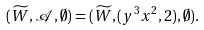Convert formula to latex. <formula><loc_0><loc_0><loc_500><loc_500>( \widetilde { W } , { \mathcal { A } } , \emptyset ) = ( \widetilde { W } , ( y ^ { 3 } x ^ { 2 } , 2 ) , \emptyset ) .</formula> 